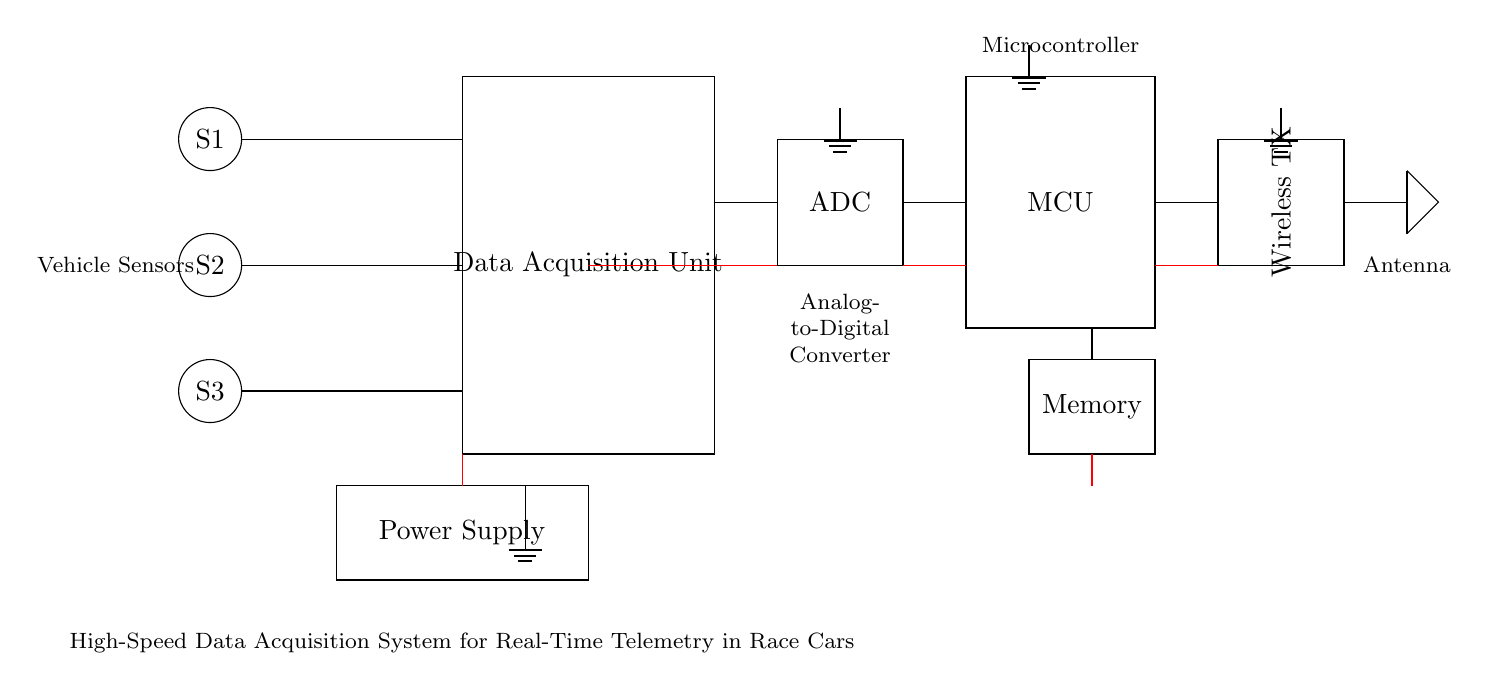What is the main function of the Data Acquisition Unit? The Data Acquisition Unit collects and processes signals from the sensors. It serves as the central hub for monitoring various telemetry data from the race car.
Answer: Data Acquisition Unit How many sensors are connected to the system? There are three sensors connected to the Data Acquisition Unit, indicated as S1, S2, and S3 in the circuit diagram.
Answer: Three sensors What is the role of the Analog-to-Digital Converter (ADC)? The ADC converts the analog signals received from the sensors into digital data, which can be processed by the microcontroller. This process is essential for digital telemetry.
Answer: Convert analog to digital Where does the power supply connect to in the circuit? The power supply connects to the Data Acquisition Unit, the ADC, the microcontroller, and the memory. All these components require power to function effectively.
Answer: Multiple connection points How does the data from the sensors reach the wireless transmitter? The data flow sequence starts from the sensors to the Data Acquisition Unit, then to the ADC, followed by the microcontroller, which finally sends the processed data to the wireless transmitter. This sequential path ensures real-time telemetry communication.
Answer: Sequential data flow What is the significance of the antenna in this setup? The antenna is crucial for wireless communication, as it transmits the telemetry data processed by the microcontroller to external devices or systems for monitoring and analysis during the race.
Answer: Wireless communication What type of telemetry is being implemented in this circuit? The telemetry being implemented is real-time telemetry, allowing instantaneous monitoring of vehicle performance and conditions during the race. This type of telemetry is vital for strategic decision-making.
Answer: Real-time telemetry 